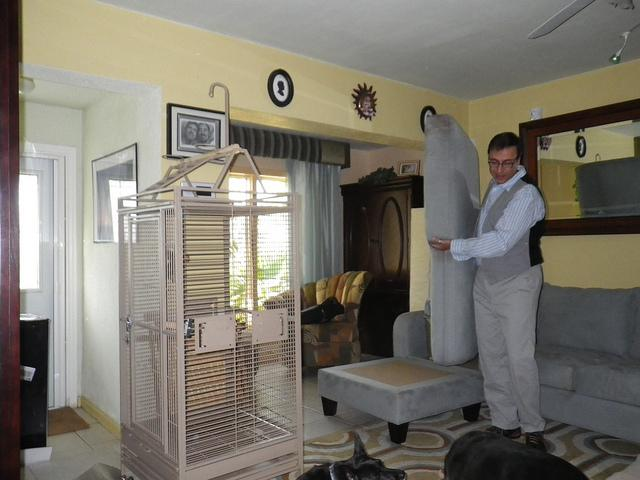Pet care Helpline number? Please explain your reasoning. 952. This is common knowledge that 952 is the pet helpline number. 